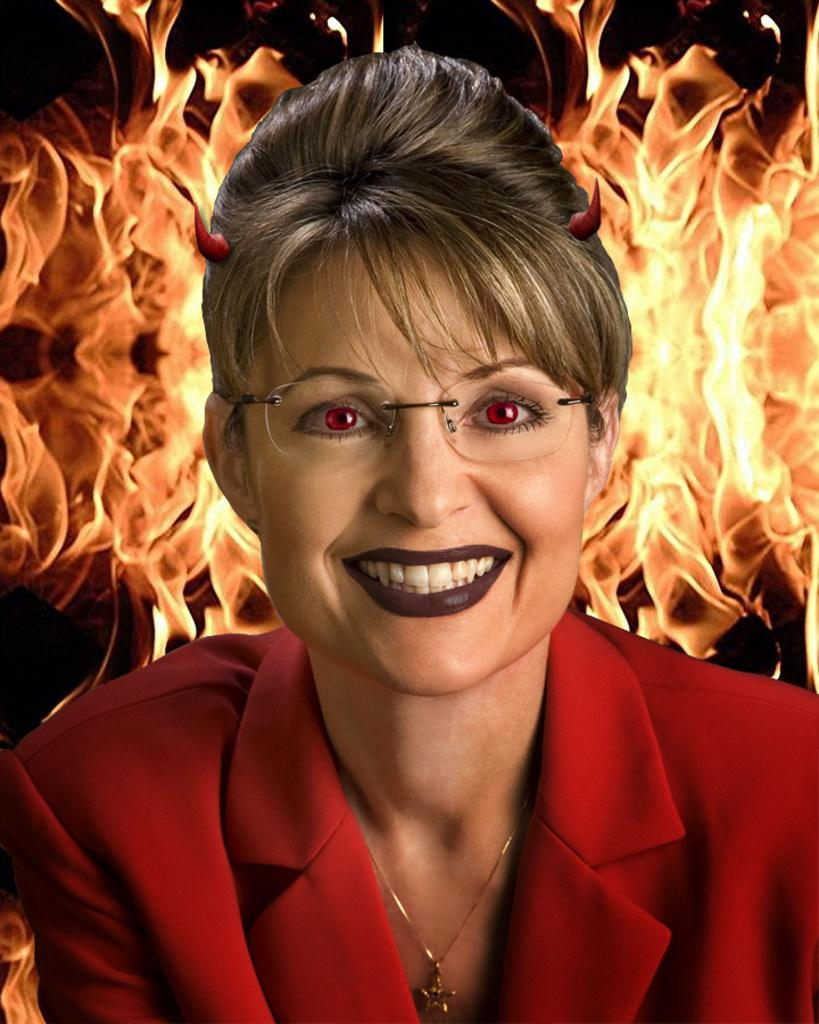Who is present in the image? There is a woman in the image. What is the woman wearing? The woman is wearing a red dress and spectacles. What expression does the woman have? The woman is smiling. What can be seen in the background of the image? There is animated fire in the background of the image, and the background is dark. How many spiders are crawling on the woman's dress in the image? There are no spiders present in the image; the woman is wearing a red dress and spectacles. What type of power source is used to create the animated fire in the background? The image does not provide information about the power source used to create the animated fire in the background. 